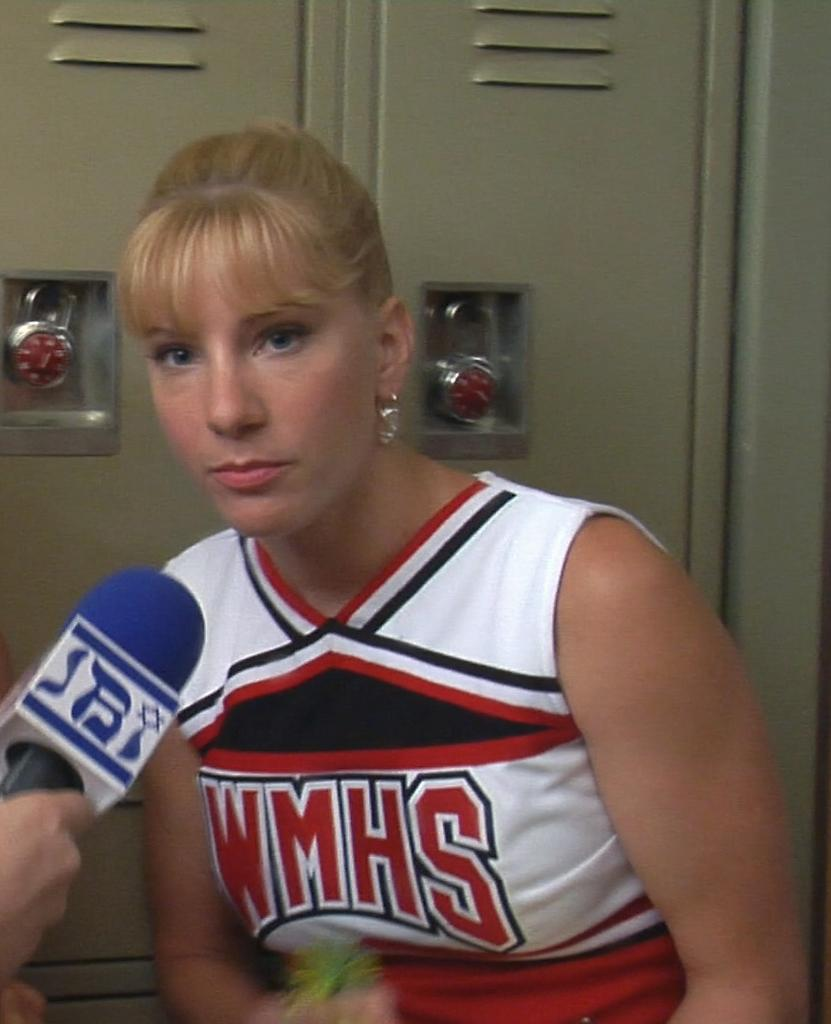Provide a one-sentence caption for the provided image. A WMHS cheerleader is speaking into a microphone. 